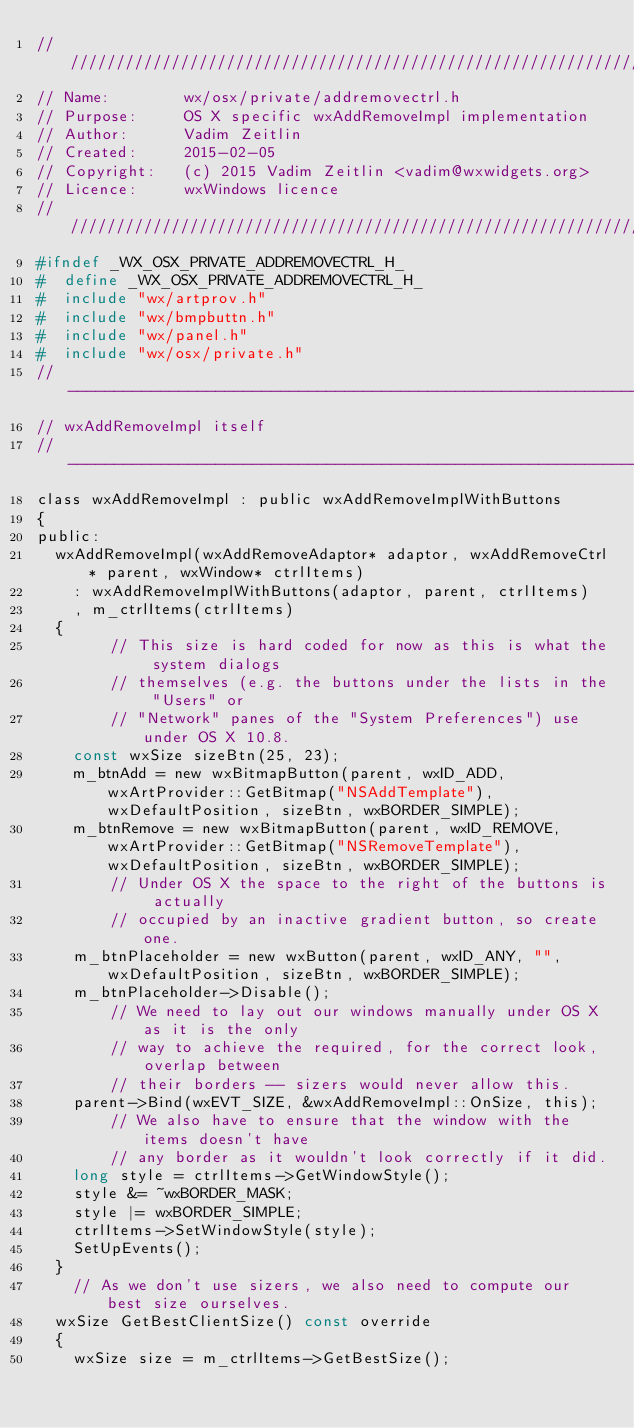Convert code to text. <code><loc_0><loc_0><loc_500><loc_500><_C_>///////////////////////////////////////////////////////////////////////////////
// Name:        wx/osx/private/addremovectrl.h
// Purpose:     OS X specific wxAddRemoveImpl implementation
// Author:      Vadim Zeitlin
// Created:     2015-02-05
// Copyright:   (c) 2015 Vadim Zeitlin <vadim@wxwidgets.org>
// Licence:     wxWindows licence
///////////////////////////////////////////////////////////////////////////////
#ifndef _WX_OSX_PRIVATE_ADDREMOVECTRL_H_
#  define _WX_OSX_PRIVATE_ADDREMOVECTRL_H_
#  include "wx/artprov.h"
#  include "wx/bmpbuttn.h"
#  include "wx/panel.h"
#  include "wx/osx/private.h"
// ----------------------------------------------------------------------------
// wxAddRemoveImpl itself
// ----------------------------------------------------------------------------
class wxAddRemoveImpl : public wxAddRemoveImplWithButtons
{
public:
  wxAddRemoveImpl(wxAddRemoveAdaptor* adaptor, wxAddRemoveCtrl* parent, wxWindow* ctrlItems)
    : wxAddRemoveImplWithButtons(adaptor, parent, ctrlItems)
    , m_ctrlItems(ctrlItems)
  {
        // This size is hard coded for now as this is what the system dialogs
        // themselves (e.g. the buttons under the lists in the "Users" or
        // "Network" panes of the "System Preferences") use under OS X 10.8.
    const wxSize sizeBtn(25, 23);
    m_btnAdd = new wxBitmapButton(parent, wxID_ADD, wxArtProvider::GetBitmap("NSAddTemplate"), wxDefaultPosition, sizeBtn, wxBORDER_SIMPLE);
    m_btnRemove = new wxBitmapButton(parent, wxID_REMOVE, wxArtProvider::GetBitmap("NSRemoveTemplate"), wxDefaultPosition, sizeBtn, wxBORDER_SIMPLE);
        // Under OS X the space to the right of the buttons is actually
        // occupied by an inactive gradient button, so create one.
    m_btnPlaceholder = new wxButton(parent, wxID_ANY, "", wxDefaultPosition, sizeBtn, wxBORDER_SIMPLE);
    m_btnPlaceholder->Disable();
        // We need to lay out our windows manually under OS X as it is the only
        // way to achieve the required, for the correct look, overlap between
        // their borders -- sizers would never allow this.
    parent->Bind(wxEVT_SIZE, &wxAddRemoveImpl::OnSize, this);
        // We also have to ensure that the window with the items doesn't have
        // any border as it wouldn't look correctly if it did.
    long style = ctrlItems->GetWindowStyle();
    style &= ~wxBORDER_MASK;
    style |= wxBORDER_SIMPLE;
    ctrlItems->SetWindowStyle(style);
    SetUpEvents();
  }
    // As we don't use sizers, we also need to compute our best size ourselves.
  wxSize GetBestClientSize() const override
  {
    wxSize size = m_ctrlItems->GetBestSize();</code> 